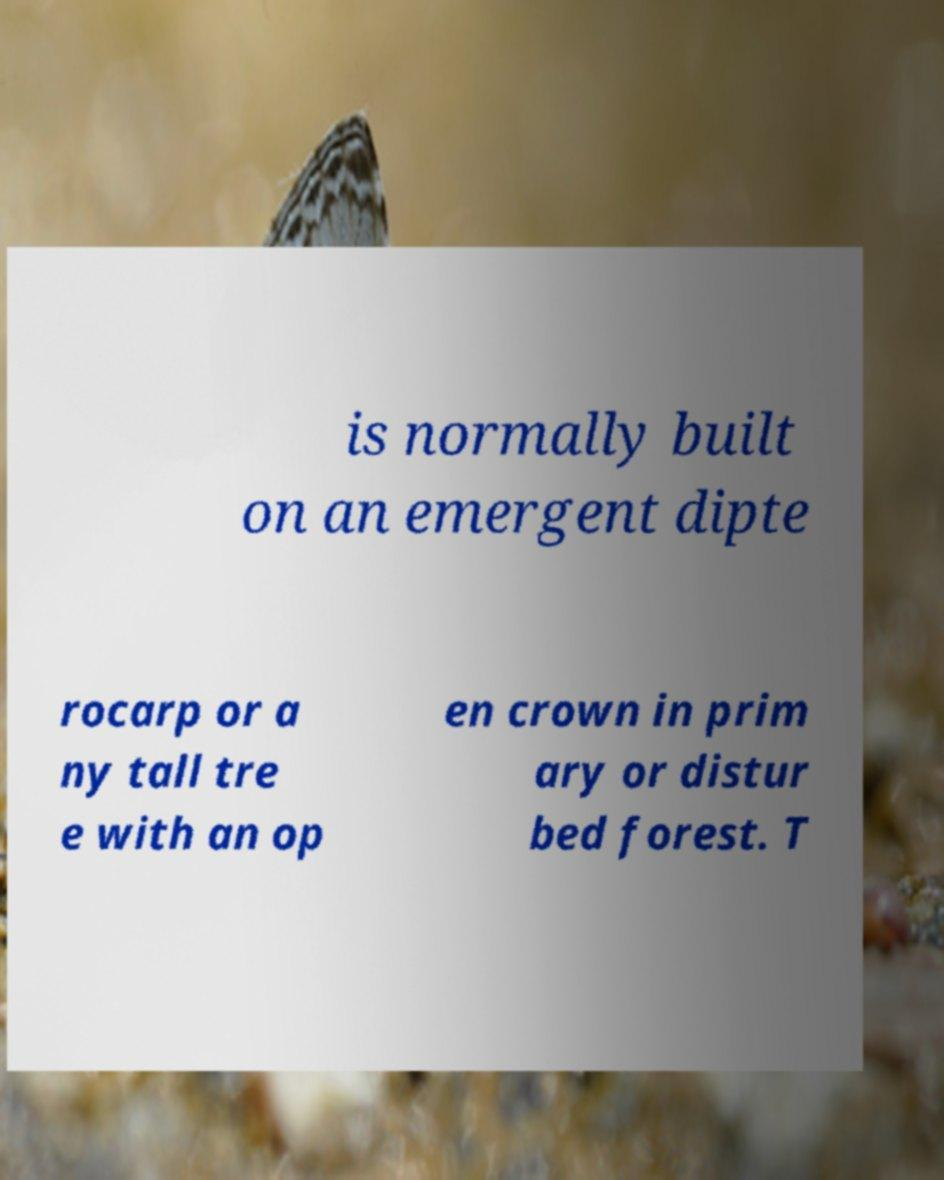What messages or text are displayed in this image? I need them in a readable, typed format. is normally built on an emergent dipte rocarp or a ny tall tre e with an op en crown in prim ary or distur bed forest. T 